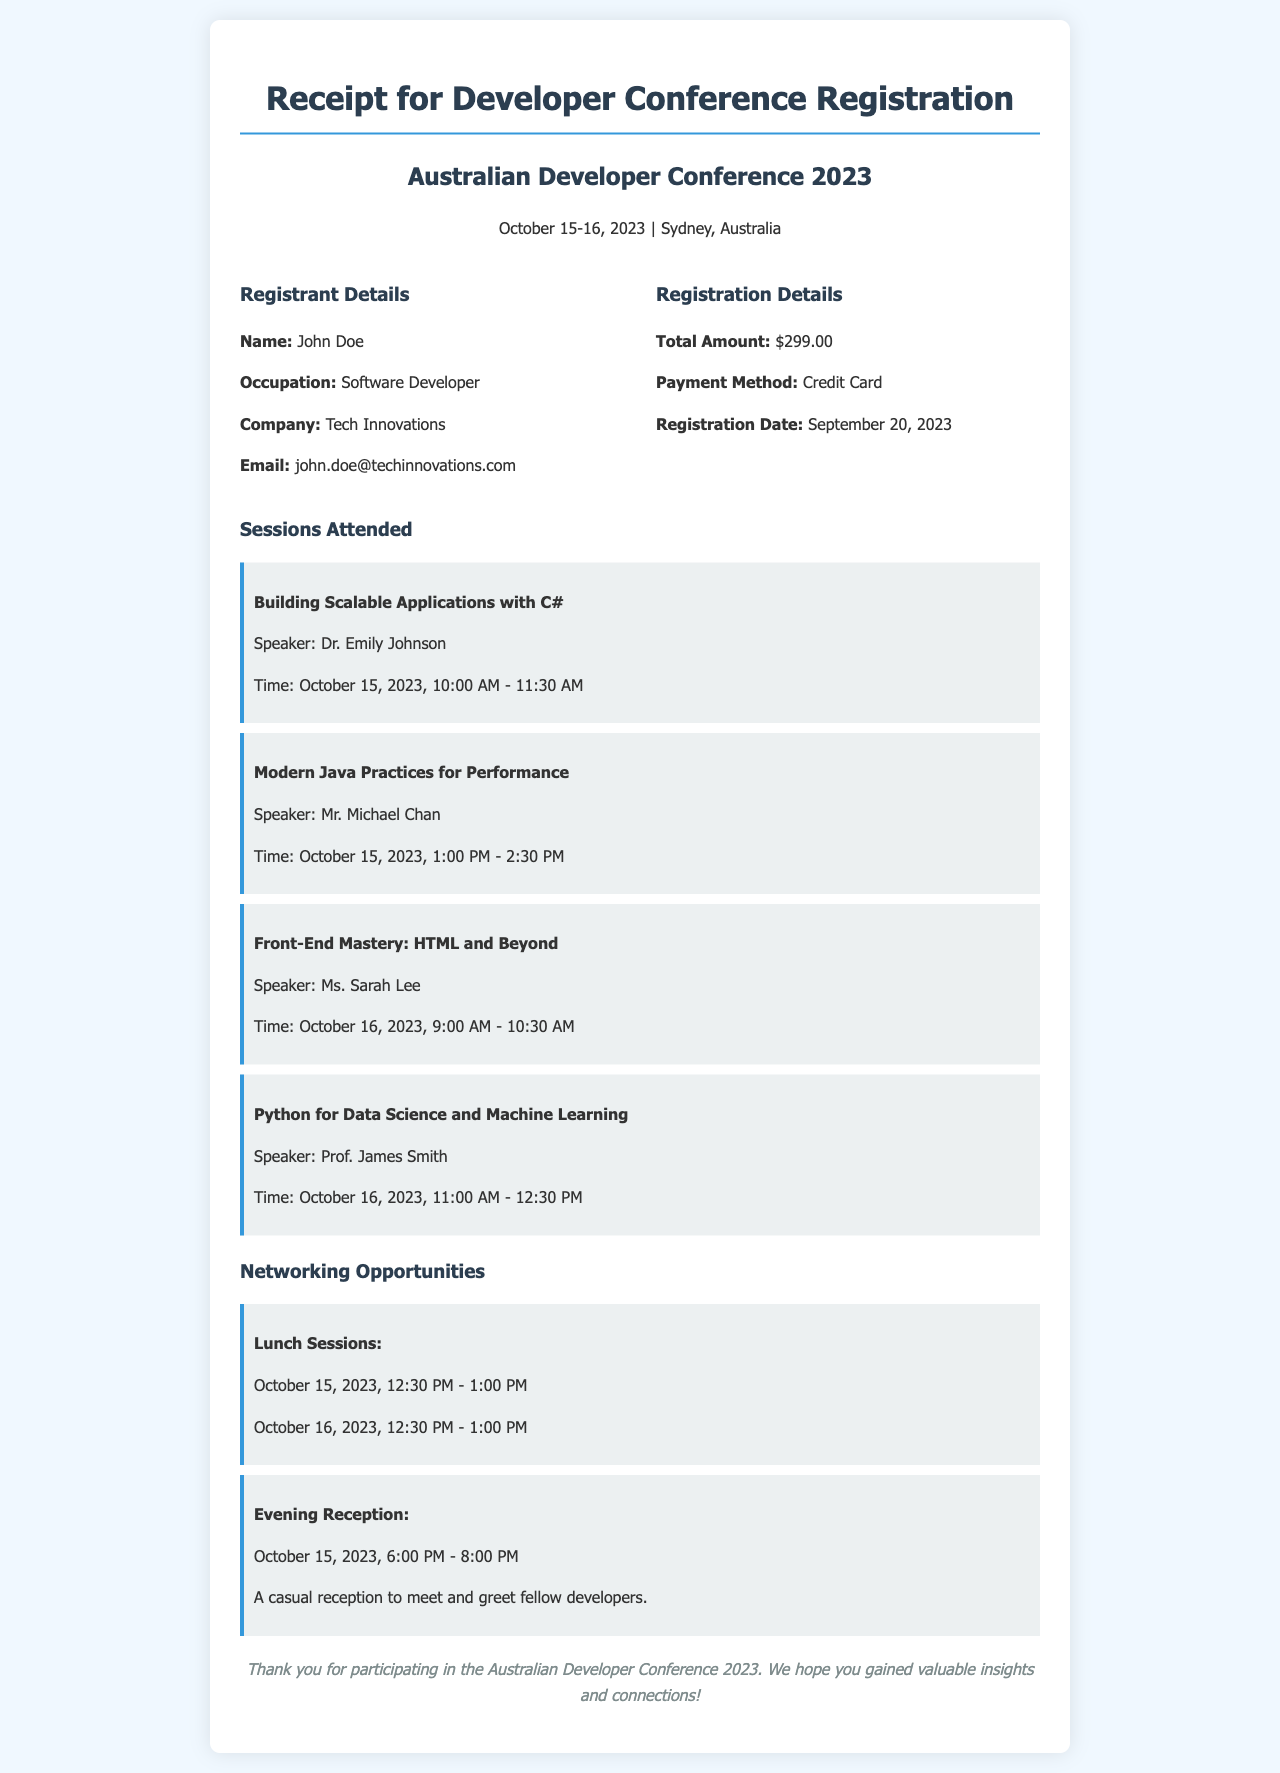what is the total amount for registration? The total amount is clearly stated in the registration details section of the document.
Answer: $299.00 who is the speaker for the session on "Building Scalable Applications with C#"? The speaker's name is provided directly under the session title in the sessions attended section.
Answer: Dr. Emily Johnson what date was the registration completed? The registration date is specified in the registration details section of the document.
Answer: September 20, 2023 how many sessions were attended? The number of sessions can be counted in the sessions attended section of the document.
Answer: Four when is the evening reception scheduled? The timing for the evening reception is mentioned under the networking opportunities section of the document.
Answer: October 15, 2023, 6:00 PM - 8:00 PM what is the email address of the registrant? The registrant's email is listed under the registrant details section of the document.
Answer: john.doe@techinnovations.com which session focuses on Python? This can be found in the session's attended section; it is clearly stated there.
Answer: Python for Data Science and Machine Learning what type of payment was used for registration? The payment method is specified in the registration details section of the document.
Answer: Credit Card what two days does the conference take place? The dates of the conference are mentioned at the top of the document.
Answer: October 15-16, 2023 